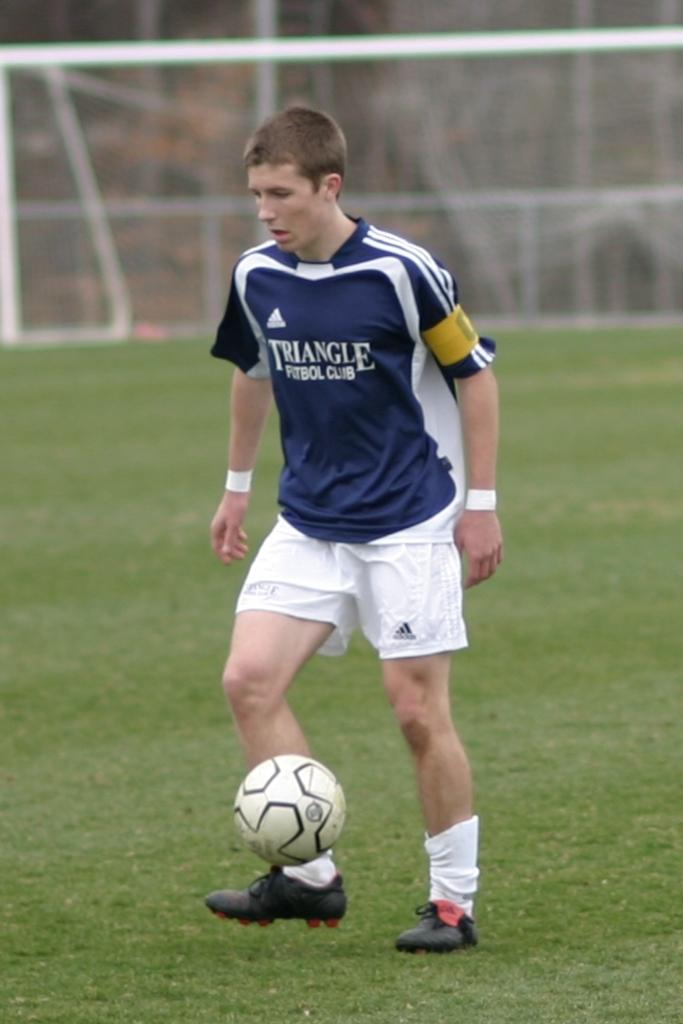Provide a one-sentence caption for the provided image. a soccer player wearing a blue jersey that says triangle futbol club. 